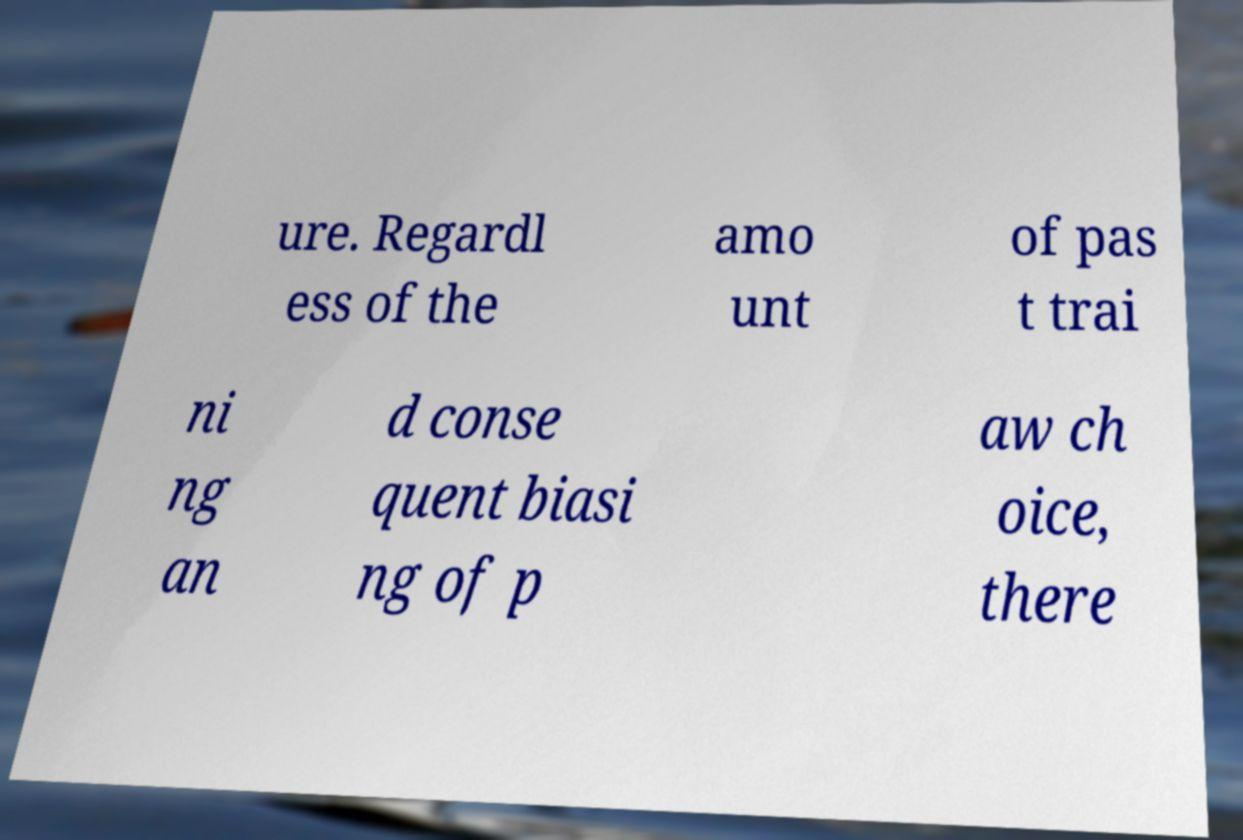Can you read and provide the text displayed in the image?This photo seems to have some interesting text. Can you extract and type it out for me? ure. Regardl ess of the amo unt of pas t trai ni ng an d conse quent biasi ng of p aw ch oice, there 